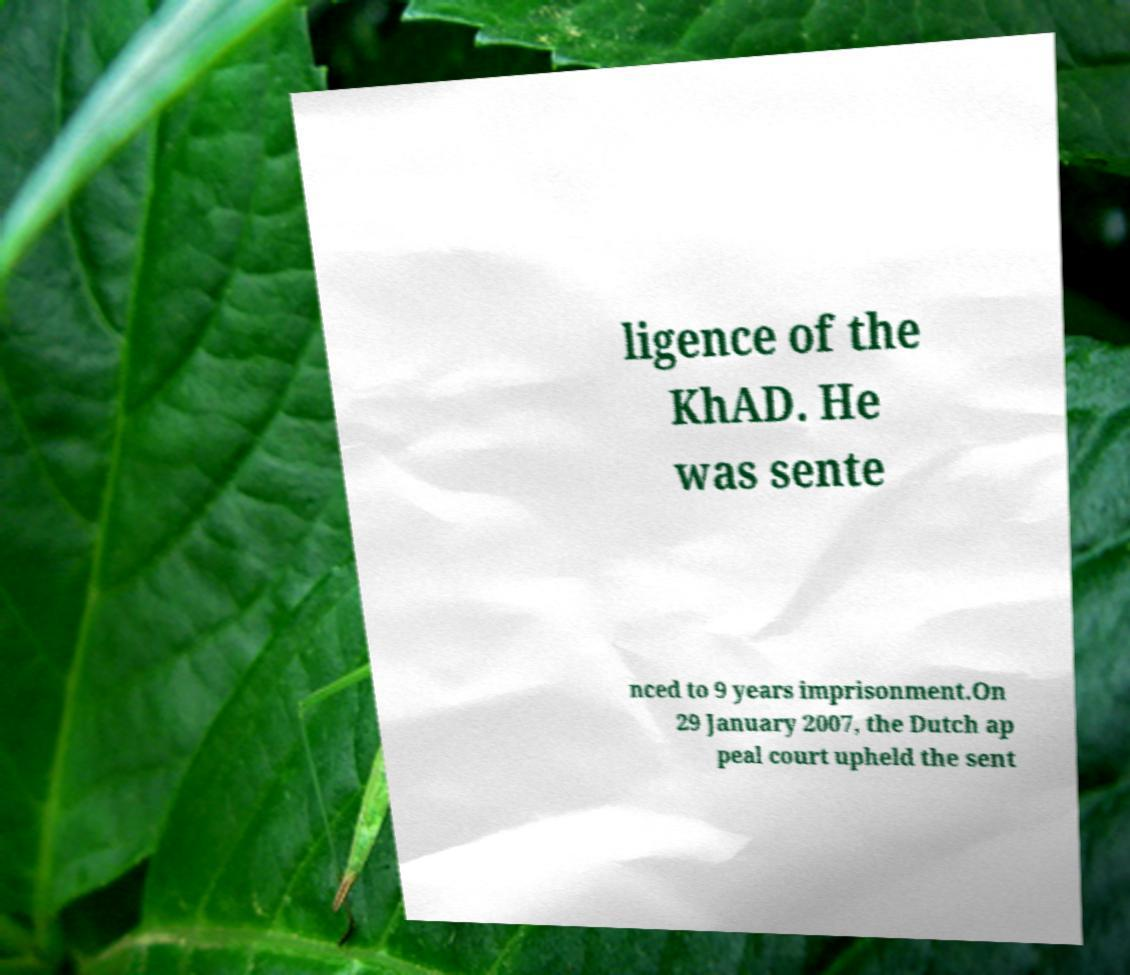Can you accurately transcribe the text from the provided image for me? ligence of the KhAD. He was sente nced to 9 years imprisonment.On 29 January 2007, the Dutch ap peal court upheld the sent 